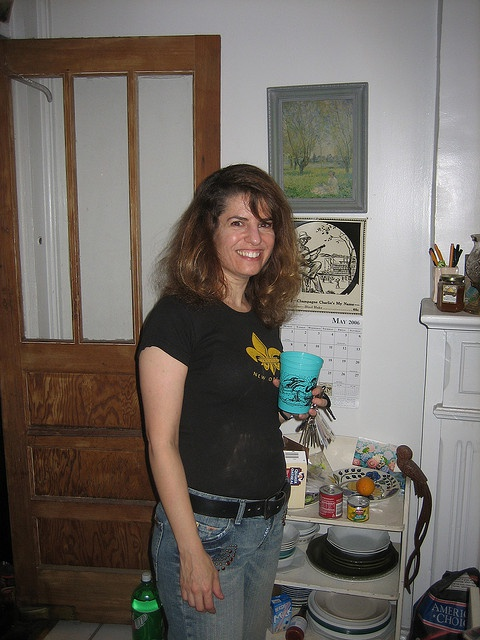Describe the objects in this image and their specific colors. I can see people in black, gray, and maroon tones, cup in black, turquoise, and teal tones, book in black, gray, and maroon tones, bottle in black, green, darkgreen, and gray tones, and bowl in black and gray tones in this image. 